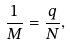<formula> <loc_0><loc_0><loc_500><loc_500>\frac { 1 } { M } = \frac { q } { N } ,</formula> 